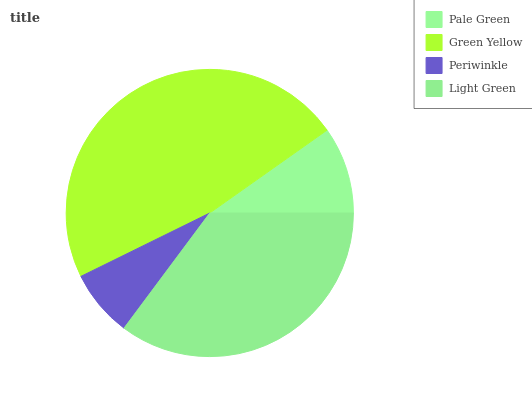Is Periwinkle the minimum?
Answer yes or no. Yes. Is Green Yellow the maximum?
Answer yes or no. Yes. Is Green Yellow the minimum?
Answer yes or no. No. Is Periwinkle the maximum?
Answer yes or no. No. Is Green Yellow greater than Periwinkle?
Answer yes or no. Yes. Is Periwinkle less than Green Yellow?
Answer yes or no. Yes. Is Periwinkle greater than Green Yellow?
Answer yes or no. No. Is Green Yellow less than Periwinkle?
Answer yes or no. No. Is Light Green the high median?
Answer yes or no. Yes. Is Pale Green the low median?
Answer yes or no. Yes. Is Periwinkle the high median?
Answer yes or no. No. Is Green Yellow the low median?
Answer yes or no. No. 